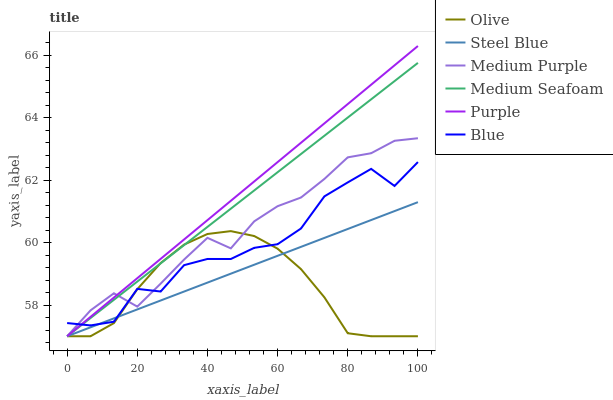Does Olive have the minimum area under the curve?
Answer yes or no. Yes. Does Purple have the maximum area under the curve?
Answer yes or no. Yes. Does Steel Blue have the minimum area under the curve?
Answer yes or no. No. Does Steel Blue have the maximum area under the curve?
Answer yes or no. No. Is Purple the smoothest?
Answer yes or no. Yes. Is Blue the roughest?
Answer yes or no. Yes. Is Steel Blue the smoothest?
Answer yes or no. No. Is Steel Blue the roughest?
Answer yes or no. No. Does Purple have the highest value?
Answer yes or no. Yes. Does Steel Blue have the highest value?
Answer yes or no. No. Does Steel Blue intersect Blue?
Answer yes or no. Yes. Is Steel Blue less than Blue?
Answer yes or no. No. Is Steel Blue greater than Blue?
Answer yes or no. No. 